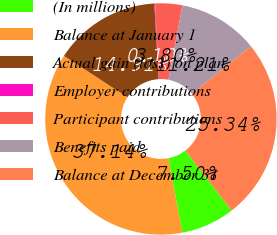Convert chart to OTSL. <chart><loc_0><loc_0><loc_500><loc_500><pie_chart><fcel>(In millions)<fcel>Balance at January 1<fcel>Actual gain (loss) on plan<fcel>Employer contributions<fcel>Participant contributions<fcel>Benefits paid<fcel>Balance at December 31<nl><fcel>7.5%<fcel>37.14%<fcel>14.91%<fcel>0.1%<fcel>3.8%<fcel>11.21%<fcel>25.34%<nl></chart> 